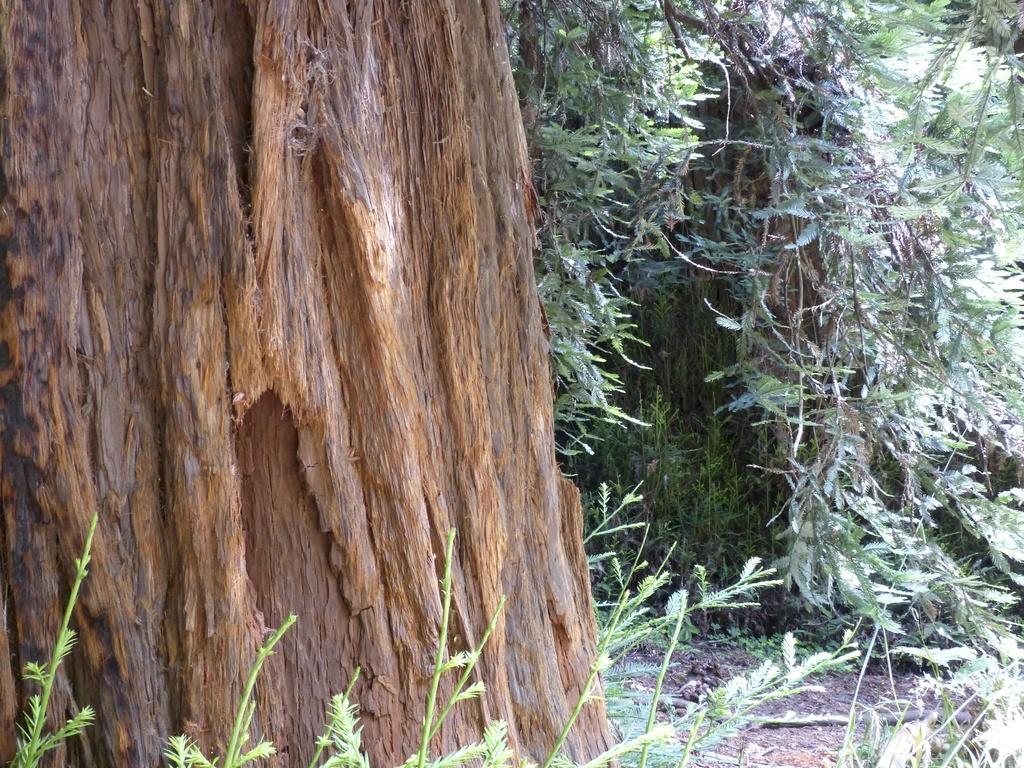Describe this image in one or two sentences. In this picture we can see a tree trunk and trees. At the bottom of the image, there are plants. 